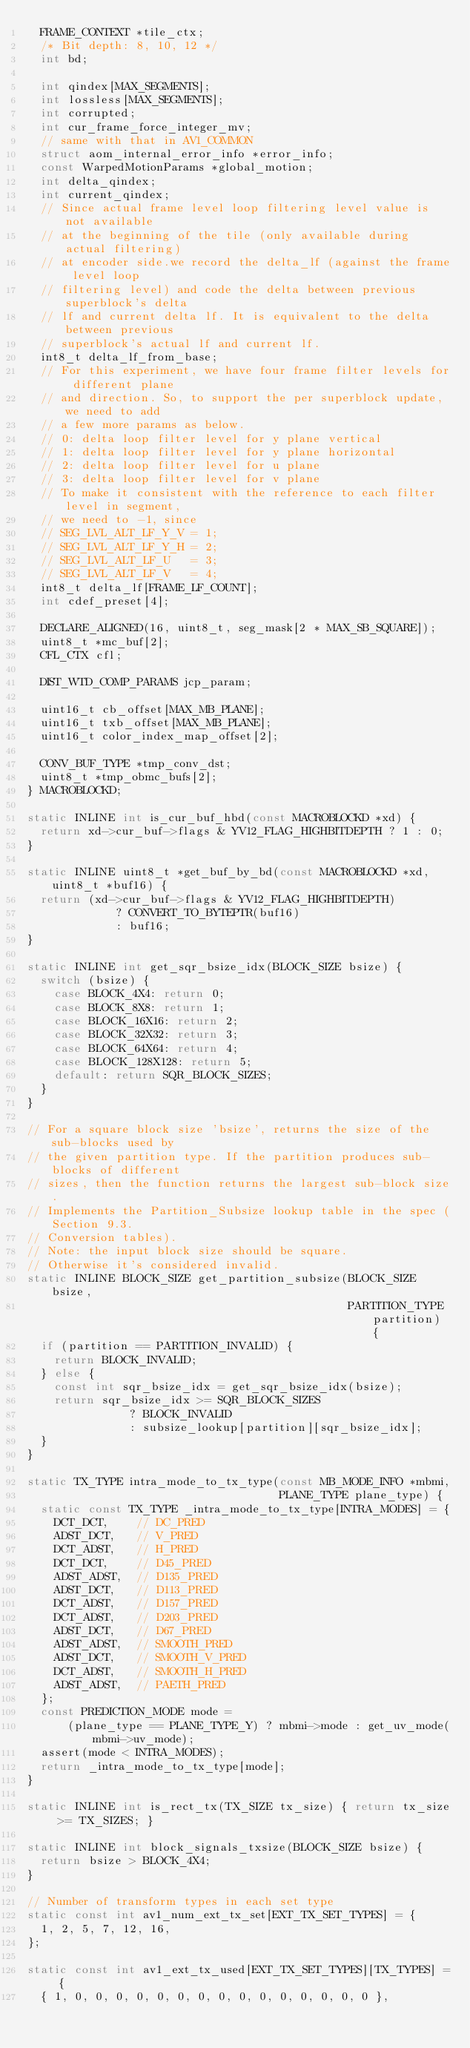Convert code to text. <code><loc_0><loc_0><loc_500><loc_500><_C_>  FRAME_CONTEXT *tile_ctx;
  /* Bit depth: 8, 10, 12 */
  int bd;

  int qindex[MAX_SEGMENTS];
  int lossless[MAX_SEGMENTS];
  int corrupted;
  int cur_frame_force_integer_mv;
  // same with that in AV1_COMMON
  struct aom_internal_error_info *error_info;
  const WarpedMotionParams *global_motion;
  int delta_qindex;
  int current_qindex;
  // Since actual frame level loop filtering level value is not available
  // at the beginning of the tile (only available during actual filtering)
  // at encoder side.we record the delta_lf (against the frame level loop
  // filtering level) and code the delta between previous superblock's delta
  // lf and current delta lf. It is equivalent to the delta between previous
  // superblock's actual lf and current lf.
  int8_t delta_lf_from_base;
  // For this experiment, we have four frame filter levels for different plane
  // and direction. So, to support the per superblock update, we need to add
  // a few more params as below.
  // 0: delta loop filter level for y plane vertical
  // 1: delta loop filter level for y plane horizontal
  // 2: delta loop filter level for u plane
  // 3: delta loop filter level for v plane
  // To make it consistent with the reference to each filter level in segment,
  // we need to -1, since
  // SEG_LVL_ALT_LF_Y_V = 1;
  // SEG_LVL_ALT_LF_Y_H = 2;
  // SEG_LVL_ALT_LF_U   = 3;
  // SEG_LVL_ALT_LF_V   = 4;
  int8_t delta_lf[FRAME_LF_COUNT];
  int cdef_preset[4];

  DECLARE_ALIGNED(16, uint8_t, seg_mask[2 * MAX_SB_SQUARE]);
  uint8_t *mc_buf[2];
  CFL_CTX cfl;

  DIST_WTD_COMP_PARAMS jcp_param;

  uint16_t cb_offset[MAX_MB_PLANE];
  uint16_t txb_offset[MAX_MB_PLANE];
  uint16_t color_index_map_offset[2];

  CONV_BUF_TYPE *tmp_conv_dst;
  uint8_t *tmp_obmc_bufs[2];
} MACROBLOCKD;

static INLINE int is_cur_buf_hbd(const MACROBLOCKD *xd) {
  return xd->cur_buf->flags & YV12_FLAG_HIGHBITDEPTH ? 1 : 0;
}

static INLINE uint8_t *get_buf_by_bd(const MACROBLOCKD *xd, uint8_t *buf16) {
  return (xd->cur_buf->flags & YV12_FLAG_HIGHBITDEPTH)
             ? CONVERT_TO_BYTEPTR(buf16)
             : buf16;
}

static INLINE int get_sqr_bsize_idx(BLOCK_SIZE bsize) {
  switch (bsize) {
    case BLOCK_4X4: return 0;
    case BLOCK_8X8: return 1;
    case BLOCK_16X16: return 2;
    case BLOCK_32X32: return 3;
    case BLOCK_64X64: return 4;
    case BLOCK_128X128: return 5;
    default: return SQR_BLOCK_SIZES;
  }
}

// For a square block size 'bsize', returns the size of the sub-blocks used by
// the given partition type. If the partition produces sub-blocks of different
// sizes, then the function returns the largest sub-block size.
// Implements the Partition_Subsize lookup table in the spec (Section 9.3.
// Conversion tables).
// Note: the input block size should be square.
// Otherwise it's considered invalid.
static INLINE BLOCK_SIZE get_partition_subsize(BLOCK_SIZE bsize,
                                               PARTITION_TYPE partition) {
  if (partition == PARTITION_INVALID) {
    return BLOCK_INVALID;
  } else {
    const int sqr_bsize_idx = get_sqr_bsize_idx(bsize);
    return sqr_bsize_idx >= SQR_BLOCK_SIZES
               ? BLOCK_INVALID
               : subsize_lookup[partition][sqr_bsize_idx];
  }
}

static TX_TYPE intra_mode_to_tx_type(const MB_MODE_INFO *mbmi,
                                     PLANE_TYPE plane_type) {
  static const TX_TYPE _intra_mode_to_tx_type[INTRA_MODES] = {
    DCT_DCT,    // DC_PRED
    ADST_DCT,   // V_PRED
    DCT_ADST,   // H_PRED
    DCT_DCT,    // D45_PRED
    ADST_ADST,  // D135_PRED
    ADST_DCT,   // D113_PRED
    DCT_ADST,   // D157_PRED
    DCT_ADST,   // D203_PRED
    ADST_DCT,   // D67_PRED
    ADST_ADST,  // SMOOTH_PRED
    ADST_DCT,   // SMOOTH_V_PRED
    DCT_ADST,   // SMOOTH_H_PRED
    ADST_ADST,  // PAETH_PRED
  };
  const PREDICTION_MODE mode =
      (plane_type == PLANE_TYPE_Y) ? mbmi->mode : get_uv_mode(mbmi->uv_mode);
  assert(mode < INTRA_MODES);
  return _intra_mode_to_tx_type[mode];
}

static INLINE int is_rect_tx(TX_SIZE tx_size) { return tx_size >= TX_SIZES; }

static INLINE int block_signals_txsize(BLOCK_SIZE bsize) {
  return bsize > BLOCK_4X4;
}

// Number of transform types in each set type
static const int av1_num_ext_tx_set[EXT_TX_SET_TYPES] = {
  1, 2, 5, 7, 12, 16,
};

static const int av1_ext_tx_used[EXT_TX_SET_TYPES][TX_TYPES] = {
  { 1, 0, 0, 0, 0, 0, 0, 0, 0, 0, 0, 0, 0, 0, 0, 0 },</code> 